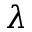<formula> <loc_0><loc_0><loc_500><loc_500>\lambda</formula> 